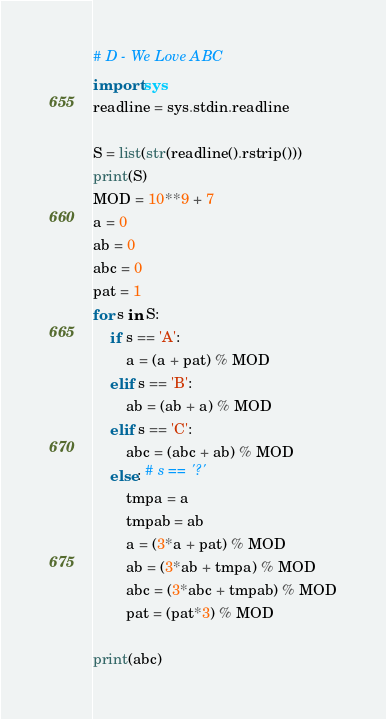<code> <loc_0><loc_0><loc_500><loc_500><_Python_># D - We Love ABC
import sys
readline = sys.stdin.readline

S = list(str(readline().rstrip()))
print(S)
MOD = 10**9 + 7
a = 0
ab = 0
abc = 0
pat = 1
for s in S:
    if s == 'A':
        a = (a + pat) % MOD
    elif s == 'B':
        ab = (ab + a) % MOD
    elif s == 'C':
        abc = (abc + ab) % MOD
    else: # s == '?'
        tmpa = a
        tmpab = ab
        a = (3*a + pat) % MOD
        ab = (3*ab + tmpa) % MOD
        abc = (3*abc + tmpab) % MOD
        pat = (pat*3) % MOD

print(abc)</code> 